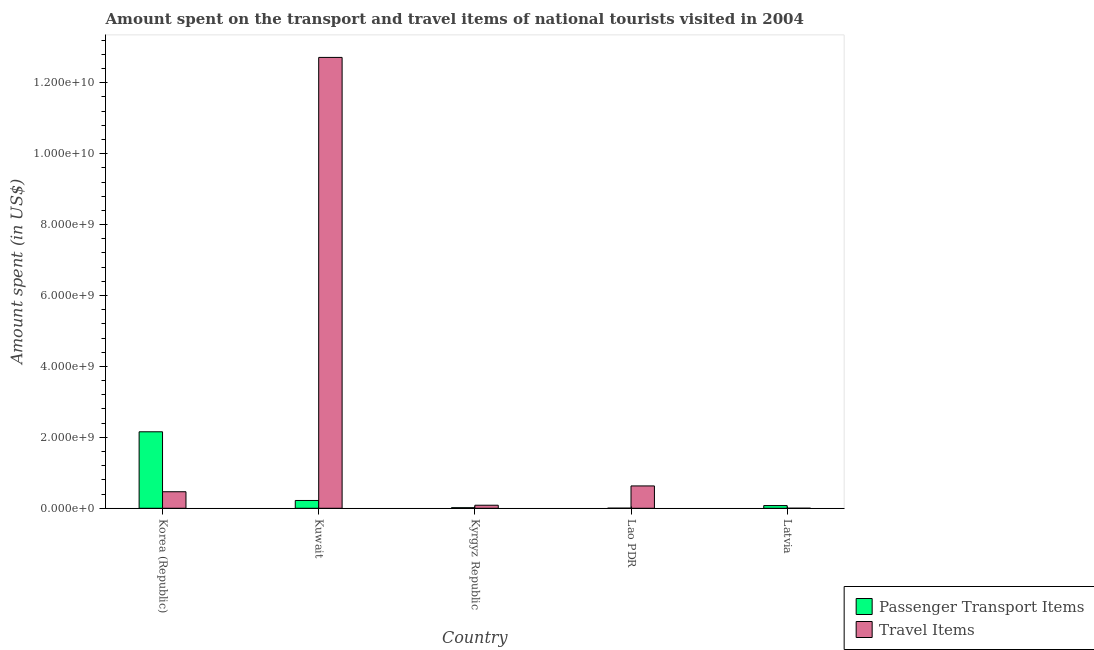How many groups of bars are there?
Provide a succinct answer. 5. Are the number of bars per tick equal to the number of legend labels?
Make the answer very short. Yes. Are the number of bars on each tick of the X-axis equal?
Your answer should be very brief. Yes. How many bars are there on the 2nd tick from the left?
Make the answer very short. 2. How many bars are there on the 1st tick from the right?
Provide a succinct answer. 2. In how many cases, is the number of bars for a given country not equal to the number of legend labels?
Give a very brief answer. 0. What is the amount spent in travel items in Lao PDR?
Provide a succinct answer. 6.30e+08. Across all countries, what is the maximum amount spent in travel items?
Make the answer very short. 1.27e+1. Across all countries, what is the minimum amount spent on passenger transport items?
Ensure brevity in your answer.  3.00e+06. In which country was the amount spent on passenger transport items maximum?
Your answer should be very brief. Korea (Republic). In which country was the amount spent on passenger transport items minimum?
Make the answer very short. Lao PDR. What is the total amount spent on passenger transport items in the graph?
Your answer should be very brief. 2.47e+09. What is the difference between the amount spent on passenger transport items in Kuwait and that in Latvia?
Offer a very short reply. 1.44e+08. What is the difference between the amount spent in travel items in Lao PDR and the amount spent on passenger transport items in Korea (Republic)?
Offer a very short reply. -1.53e+09. What is the average amount spent on passenger transport items per country?
Offer a very short reply. 4.94e+08. What is the difference between the amount spent in travel items and amount spent on passenger transport items in Latvia?
Ensure brevity in your answer.  -7.50e+07. What is the ratio of the amount spent in travel items in Korea (Republic) to that in Kuwait?
Your answer should be very brief. 0.04. What is the difference between the highest and the second highest amount spent on passenger transport items?
Make the answer very short. 1.94e+09. What is the difference between the highest and the lowest amount spent in travel items?
Your answer should be compact. 1.27e+1. In how many countries, is the amount spent on passenger transport items greater than the average amount spent on passenger transport items taken over all countries?
Your response must be concise. 1. What does the 2nd bar from the left in Lao PDR represents?
Your answer should be very brief. Travel Items. What does the 1st bar from the right in Kuwait represents?
Give a very brief answer. Travel Items. How many bars are there?
Your answer should be compact. 10. What is the difference between two consecutive major ticks on the Y-axis?
Provide a short and direct response. 2.00e+09. Are the values on the major ticks of Y-axis written in scientific E-notation?
Offer a terse response. Yes. Where does the legend appear in the graph?
Provide a succinct answer. Bottom right. How many legend labels are there?
Provide a succinct answer. 2. What is the title of the graph?
Your answer should be compact. Amount spent on the transport and travel items of national tourists visited in 2004. What is the label or title of the X-axis?
Your response must be concise. Country. What is the label or title of the Y-axis?
Give a very brief answer. Amount spent (in US$). What is the Amount spent (in US$) in Passenger Transport Items in Korea (Republic)?
Provide a short and direct response. 2.16e+09. What is the Amount spent (in US$) of Travel Items in Korea (Republic)?
Ensure brevity in your answer.  4.66e+08. What is the Amount spent (in US$) of Passenger Transport Items in Kuwait?
Ensure brevity in your answer.  2.20e+08. What is the Amount spent (in US$) of Travel Items in Kuwait?
Your answer should be compact. 1.27e+1. What is the Amount spent (in US$) in Passenger Transport Items in Kyrgyz Republic?
Provide a succinct answer. 1.60e+07. What is the Amount spent (in US$) of Travel Items in Kyrgyz Republic?
Keep it short and to the point. 8.60e+07. What is the Amount spent (in US$) of Travel Items in Lao PDR?
Provide a succinct answer. 6.30e+08. What is the Amount spent (in US$) of Passenger Transport Items in Latvia?
Your response must be concise. 7.60e+07. What is the Amount spent (in US$) of Travel Items in Latvia?
Ensure brevity in your answer.  1.00e+06. Across all countries, what is the maximum Amount spent (in US$) in Passenger Transport Items?
Offer a very short reply. 2.16e+09. Across all countries, what is the maximum Amount spent (in US$) in Travel Items?
Provide a short and direct response. 1.27e+1. Across all countries, what is the minimum Amount spent (in US$) of Passenger Transport Items?
Your answer should be compact. 3.00e+06. Across all countries, what is the minimum Amount spent (in US$) in Travel Items?
Give a very brief answer. 1.00e+06. What is the total Amount spent (in US$) in Passenger Transport Items in the graph?
Offer a terse response. 2.47e+09. What is the total Amount spent (in US$) in Travel Items in the graph?
Your answer should be very brief. 1.39e+1. What is the difference between the Amount spent (in US$) in Passenger Transport Items in Korea (Republic) and that in Kuwait?
Ensure brevity in your answer.  1.94e+09. What is the difference between the Amount spent (in US$) in Travel Items in Korea (Republic) and that in Kuwait?
Offer a terse response. -1.22e+1. What is the difference between the Amount spent (in US$) of Passenger Transport Items in Korea (Republic) and that in Kyrgyz Republic?
Provide a succinct answer. 2.14e+09. What is the difference between the Amount spent (in US$) in Travel Items in Korea (Republic) and that in Kyrgyz Republic?
Provide a short and direct response. 3.80e+08. What is the difference between the Amount spent (in US$) of Passenger Transport Items in Korea (Republic) and that in Lao PDR?
Your response must be concise. 2.15e+09. What is the difference between the Amount spent (in US$) in Travel Items in Korea (Republic) and that in Lao PDR?
Keep it short and to the point. -1.64e+08. What is the difference between the Amount spent (in US$) of Passenger Transport Items in Korea (Republic) and that in Latvia?
Make the answer very short. 2.08e+09. What is the difference between the Amount spent (in US$) in Travel Items in Korea (Republic) and that in Latvia?
Give a very brief answer. 4.65e+08. What is the difference between the Amount spent (in US$) in Passenger Transport Items in Kuwait and that in Kyrgyz Republic?
Provide a succinct answer. 2.04e+08. What is the difference between the Amount spent (in US$) in Travel Items in Kuwait and that in Kyrgyz Republic?
Ensure brevity in your answer.  1.26e+1. What is the difference between the Amount spent (in US$) of Passenger Transport Items in Kuwait and that in Lao PDR?
Give a very brief answer. 2.17e+08. What is the difference between the Amount spent (in US$) of Travel Items in Kuwait and that in Lao PDR?
Ensure brevity in your answer.  1.21e+1. What is the difference between the Amount spent (in US$) of Passenger Transport Items in Kuwait and that in Latvia?
Offer a terse response. 1.44e+08. What is the difference between the Amount spent (in US$) of Travel Items in Kuwait and that in Latvia?
Make the answer very short. 1.27e+1. What is the difference between the Amount spent (in US$) of Passenger Transport Items in Kyrgyz Republic and that in Lao PDR?
Make the answer very short. 1.30e+07. What is the difference between the Amount spent (in US$) of Travel Items in Kyrgyz Republic and that in Lao PDR?
Offer a terse response. -5.44e+08. What is the difference between the Amount spent (in US$) in Passenger Transport Items in Kyrgyz Republic and that in Latvia?
Provide a succinct answer. -6.00e+07. What is the difference between the Amount spent (in US$) of Travel Items in Kyrgyz Republic and that in Latvia?
Offer a very short reply. 8.50e+07. What is the difference between the Amount spent (in US$) in Passenger Transport Items in Lao PDR and that in Latvia?
Offer a very short reply. -7.30e+07. What is the difference between the Amount spent (in US$) in Travel Items in Lao PDR and that in Latvia?
Provide a succinct answer. 6.29e+08. What is the difference between the Amount spent (in US$) in Passenger Transport Items in Korea (Republic) and the Amount spent (in US$) in Travel Items in Kuwait?
Make the answer very short. -1.06e+1. What is the difference between the Amount spent (in US$) of Passenger Transport Items in Korea (Republic) and the Amount spent (in US$) of Travel Items in Kyrgyz Republic?
Ensure brevity in your answer.  2.07e+09. What is the difference between the Amount spent (in US$) in Passenger Transport Items in Korea (Republic) and the Amount spent (in US$) in Travel Items in Lao PDR?
Ensure brevity in your answer.  1.53e+09. What is the difference between the Amount spent (in US$) in Passenger Transport Items in Korea (Republic) and the Amount spent (in US$) in Travel Items in Latvia?
Make the answer very short. 2.16e+09. What is the difference between the Amount spent (in US$) of Passenger Transport Items in Kuwait and the Amount spent (in US$) of Travel Items in Kyrgyz Republic?
Provide a succinct answer. 1.34e+08. What is the difference between the Amount spent (in US$) in Passenger Transport Items in Kuwait and the Amount spent (in US$) in Travel Items in Lao PDR?
Offer a terse response. -4.10e+08. What is the difference between the Amount spent (in US$) of Passenger Transport Items in Kuwait and the Amount spent (in US$) of Travel Items in Latvia?
Ensure brevity in your answer.  2.19e+08. What is the difference between the Amount spent (in US$) of Passenger Transport Items in Kyrgyz Republic and the Amount spent (in US$) of Travel Items in Lao PDR?
Keep it short and to the point. -6.14e+08. What is the difference between the Amount spent (in US$) of Passenger Transport Items in Kyrgyz Republic and the Amount spent (in US$) of Travel Items in Latvia?
Keep it short and to the point. 1.50e+07. What is the average Amount spent (in US$) of Passenger Transport Items per country?
Your answer should be compact. 4.94e+08. What is the average Amount spent (in US$) of Travel Items per country?
Offer a terse response. 2.78e+09. What is the difference between the Amount spent (in US$) in Passenger Transport Items and Amount spent (in US$) in Travel Items in Korea (Republic)?
Keep it short and to the point. 1.69e+09. What is the difference between the Amount spent (in US$) of Passenger Transport Items and Amount spent (in US$) of Travel Items in Kuwait?
Provide a succinct answer. -1.25e+1. What is the difference between the Amount spent (in US$) of Passenger Transport Items and Amount spent (in US$) of Travel Items in Kyrgyz Republic?
Make the answer very short. -7.00e+07. What is the difference between the Amount spent (in US$) of Passenger Transport Items and Amount spent (in US$) of Travel Items in Lao PDR?
Provide a succinct answer. -6.27e+08. What is the difference between the Amount spent (in US$) in Passenger Transport Items and Amount spent (in US$) in Travel Items in Latvia?
Offer a terse response. 7.50e+07. What is the ratio of the Amount spent (in US$) of Passenger Transport Items in Korea (Republic) to that in Kuwait?
Keep it short and to the point. 9.8. What is the ratio of the Amount spent (in US$) of Travel Items in Korea (Republic) to that in Kuwait?
Offer a terse response. 0.04. What is the ratio of the Amount spent (in US$) of Passenger Transport Items in Korea (Republic) to that in Kyrgyz Republic?
Your answer should be very brief. 134.81. What is the ratio of the Amount spent (in US$) in Travel Items in Korea (Republic) to that in Kyrgyz Republic?
Provide a short and direct response. 5.42. What is the ratio of the Amount spent (in US$) in Passenger Transport Items in Korea (Republic) to that in Lao PDR?
Offer a very short reply. 719. What is the ratio of the Amount spent (in US$) of Travel Items in Korea (Republic) to that in Lao PDR?
Make the answer very short. 0.74. What is the ratio of the Amount spent (in US$) of Passenger Transport Items in Korea (Republic) to that in Latvia?
Offer a terse response. 28.38. What is the ratio of the Amount spent (in US$) in Travel Items in Korea (Republic) to that in Latvia?
Make the answer very short. 466. What is the ratio of the Amount spent (in US$) in Passenger Transport Items in Kuwait to that in Kyrgyz Republic?
Offer a very short reply. 13.75. What is the ratio of the Amount spent (in US$) of Travel Items in Kuwait to that in Kyrgyz Republic?
Your response must be concise. 147.85. What is the ratio of the Amount spent (in US$) in Passenger Transport Items in Kuwait to that in Lao PDR?
Offer a terse response. 73.33. What is the ratio of the Amount spent (in US$) in Travel Items in Kuwait to that in Lao PDR?
Your answer should be very brief. 20.18. What is the ratio of the Amount spent (in US$) in Passenger Transport Items in Kuwait to that in Latvia?
Provide a succinct answer. 2.89. What is the ratio of the Amount spent (in US$) in Travel Items in Kuwait to that in Latvia?
Your answer should be very brief. 1.27e+04. What is the ratio of the Amount spent (in US$) in Passenger Transport Items in Kyrgyz Republic to that in Lao PDR?
Offer a terse response. 5.33. What is the ratio of the Amount spent (in US$) of Travel Items in Kyrgyz Republic to that in Lao PDR?
Offer a terse response. 0.14. What is the ratio of the Amount spent (in US$) in Passenger Transport Items in Kyrgyz Republic to that in Latvia?
Offer a very short reply. 0.21. What is the ratio of the Amount spent (in US$) in Passenger Transport Items in Lao PDR to that in Latvia?
Provide a short and direct response. 0.04. What is the ratio of the Amount spent (in US$) of Travel Items in Lao PDR to that in Latvia?
Provide a short and direct response. 630. What is the difference between the highest and the second highest Amount spent (in US$) in Passenger Transport Items?
Give a very brief answer. 1.94e+09. What is the difference between the highest and the second highest Amount spent (in US$) of Travel Items?
Your response must be concise. 1.21e+1. What is the difference between the highest and the lowest Amount spent (in US$) in Passenger Transport Items?
Your answer should be very brief. 2.15e+09. What is the difference between the highest and the lowest Amount spent (in US$) of Travel Items?
Keep it short and to the point. 1.27e+1. 